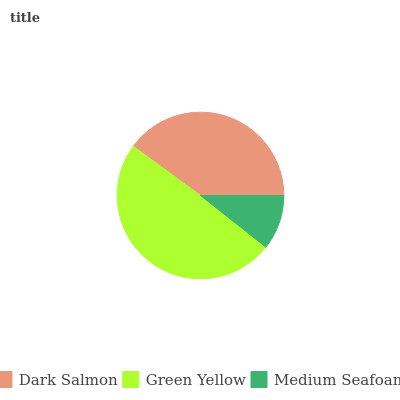Is Medium Seafoam the minimum?
Answer yes or no. Yes. Is Green Yellow the maximum?
Answer yes or no. Yes. Is Green Yellow the minimum?
Answer yes or no. No. Is Medium Seafoam the maximum?
Answer yes or no. No. Is Green Yellow greater than Medium Seafoam?
Answer yes or no. Yes. Is Medium Seafoam less than Green Yellow?
Answer yes or no. Yes. Is Medium Seafoam greater than Green Yellow?
Answer yes or no. No. Is Green Yellow less than Medium Seafoam?
Answer yes or no. No. Is Dark Salmon the high median?
Answer yes or no. Yes. Is Dark Salmon the low median?
Answer yes or no. Yes. Is Green Yellow the high median?
Answer yes or no. No. Is Medium Seafoam the low median?
Answer yes or no. No. 